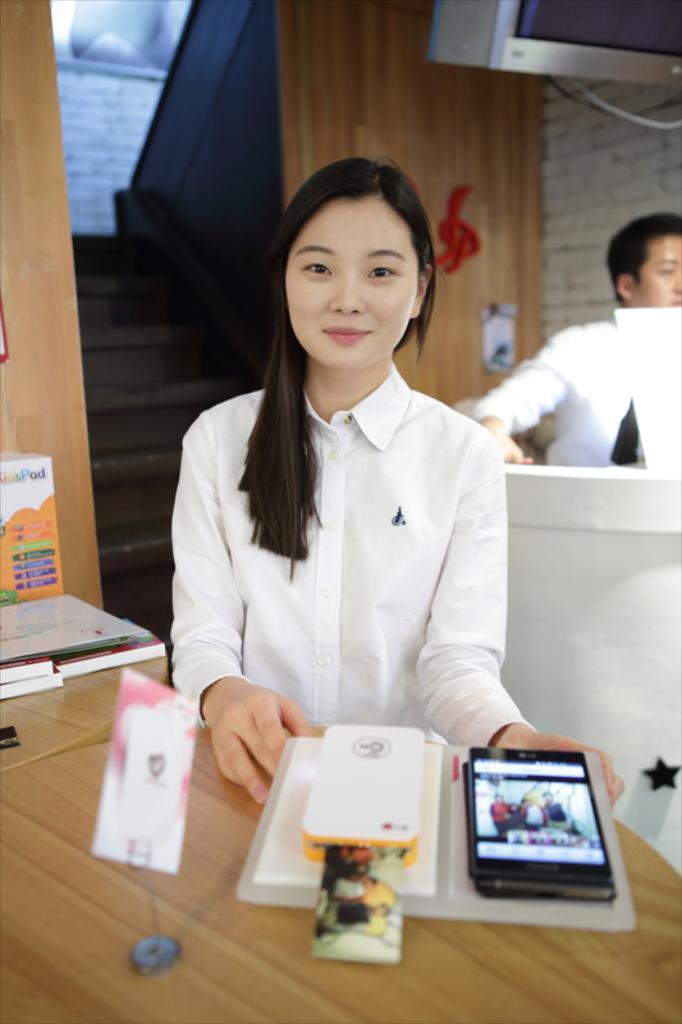Could you give a brief overview of what you see in this image? This image consists of a girl wearing a white dress. In front of her, there is a mobile kept on the desk. In the background, there is a man. The table is made up of wood. At the top, there is a screen. On the left, we can see the steps. 